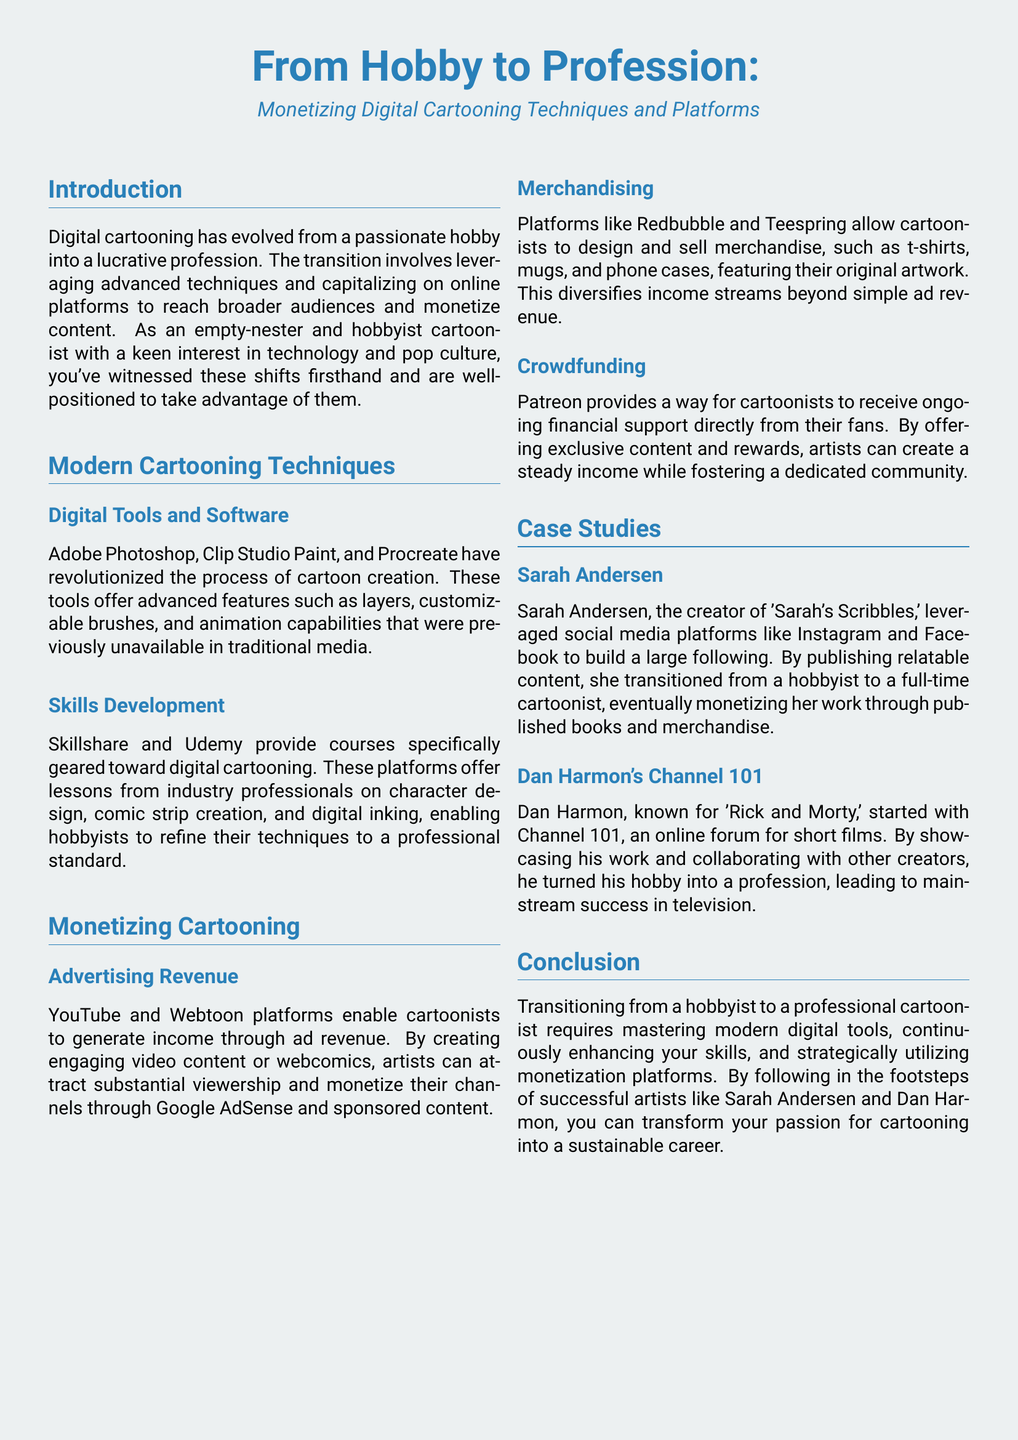What are some tools mentioned for digital cartooning? The document lists specific tools such as Adobe Photoshop, Clip Studio Paint, and Procreate for digital cartooning.
Answer: Adobe Photoshop, Clip Studio Paint, Procreate Who is the creator of 'Sarah's Scribbles'? The document identifies Sarah Andersen as the creator of 'Sarah's Scribbles', highlighting her success story.
Answer: Sarah Andersen What platform offers a way for cartoonists to receive ongoing financial support? The document states that Patreon is a platform allowing cartoonists to receive direct financial support from fans.
Answer: Patreon What is a key benefit of using Redbubble and Teespring for cartoonists? The document explains that these platforms allow cartoonists to design and sell merchandise, thus diversifying income streams.
Answer: Merchandising What is one outcome of Dan Harmon's work with Channel 101? The document indicates that Dan Harmon turned his hobby into a profession, leading to mainstream success in television.
Answer: Success in television What type of courses do Skillshare and Udemy provide? According to the document, these platforms offer courses specifically geared toward digital cartooning skills development.
Answer: Digital cartooning courses What is a common strategy used by successful cartoonists like Sarah Andersen? The document suggests that building a large following on social media platforms is a common strategy.
Answer: Social media following What is the primary focus of the case study? The document’s primary focus is on transitioning from a hobbyist to a professional cartoonist by monetizing digital techniques.
Answer: Monetizing digital techniques 